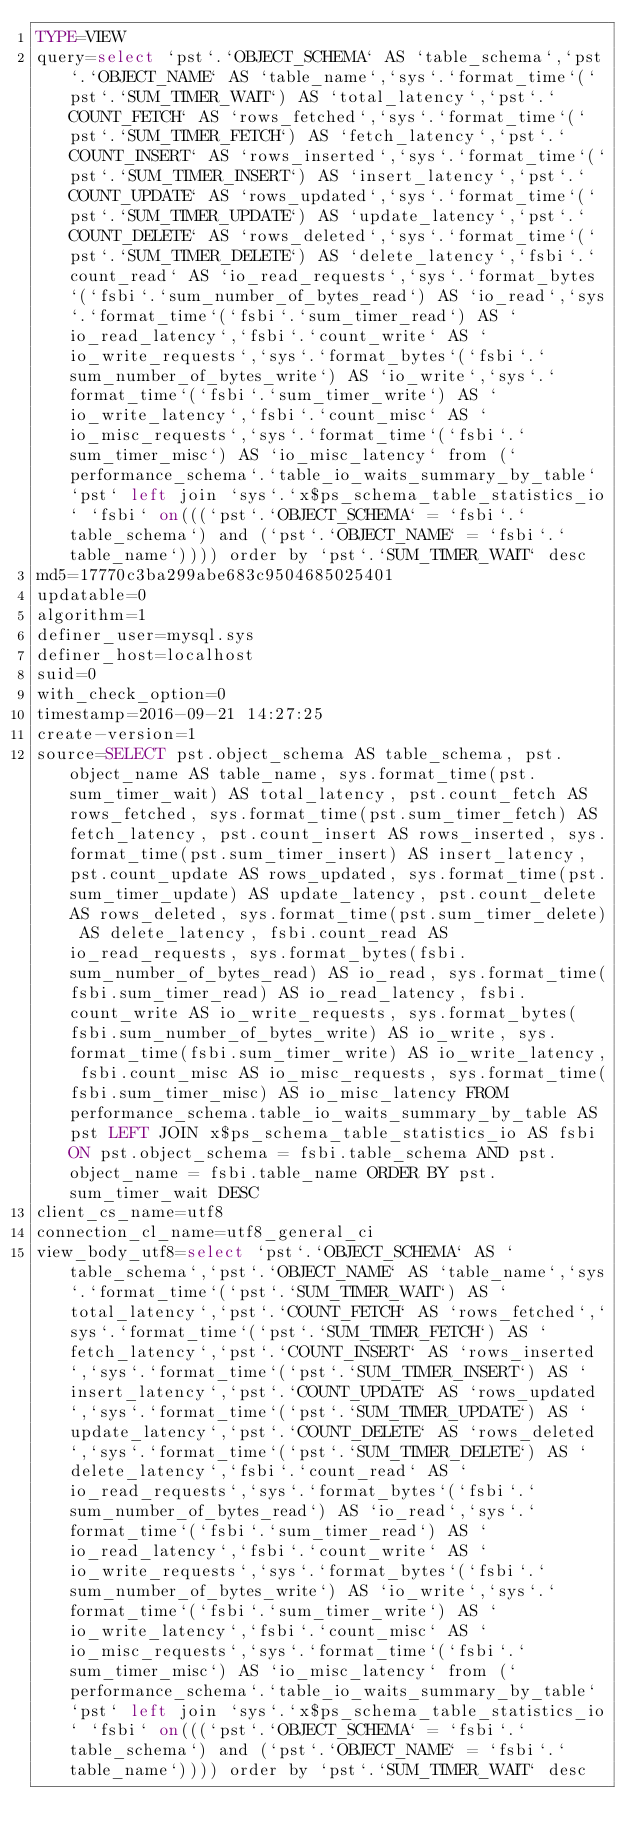Convert code to text. <code><loc_0><loc_0><loc_500><loc_500><_VisualBasic_>TYPE=VIEW
query=select `pst`.`OBJECT_SCHEMA` AS `table_schema`,`pst`.`OBJECT_NAME` AS `table_name`,`sys`.`format_time`(`pst`.`SUM_TIMER_WAIT`) AS `total_latency`,`pst`.`COUNT_FETCH` AS `rows_fetched`,`sys`.`format_time`(`pst`.`SUM_TIMER_FETCH`) AS `fetch_latency`,`pst`.`COUNT_INSERT` AS `rows_inserted`,`sys`.`format_time`(`pst`.`SUM_TIMER_INSERT`) AS `insert_latency`,`pst`.`COUNT_UPDATE` AS `rows_updated`,`sys`.`format_time`(`pst`.`SUM_TIMER_UPDATE`) AS `update_latency`,`pst`.`COUNT_DELETE` AS `rows_deleted`,`sys`.`format_time`(`pst`.`SUM_TIMER_DELETE`) AS `delete_latency`,`fsbi`.`count_read` AS `io_read_requests`,`sys`.`format_bytes`(`fsbi`.`sum_number_of_bytes_read`) AS `io_read`,`sys`.`format_time`(`fsbi`.`sum_timer_read`) AS `io_read_latency`,`fsbi`.`count_write` AS `io_write_requests`,`sys`.`format_bytes`(`fsbi`.`sum_number_of_bytes_write`) AS `io_write`,`sys`.`format_time`(`fsbi`.`sum_timer_write`) AS `io_write_latency`,`fsbi`.`count_misc` AS `io_misc_requests`,`sys`.`format_time`(`fsbi`.`sum_timer_misc`) AS `io_misc_latency` from (`performance_schema`.`table_io_waits_summary_by_table` `pst` left join `sys`.`x$ps_schema_table_statistics_io` `fsbi` on(((`pst`.`OBJECT_SCHEMA` = `fsbi`.`table_schema`) and (`pst`.`OBJECT_NAME` = `fsbi`.`table_name`)))) order by `pst`.`SUM_TIMER_WAIT` desc
md5=17770c3ba299abe683c9504685025401
updatable=0
algorithm=1
definer_user=mysql.sys
definer_host=localhost
suid=0
with_check_option=0
timestamp=2016-09-21 14:27:25
create-version=1
source=SELECT pst.object_schema AS table_schema, pst.object_name AS table_name, sys.format_time(pst.sum_timer_wait) AS total_latency, pst.count_fetch AS rows_fetched, sys.format_time(pst.sum_timer_fetch) AS fetch_latency, pst.count_insert AS rows_inserted, sys.format_time(pst.sum_timer_insert) AS insert_latency, pst.count_update AS rows_updated, sys.format_time(pst.sum_timer_update) AS update_latency, pst.count_delete AS rows_deleted, sys.format_time(pst.sum_timer_delete) AS delete_latency, fsbi.count_read AS io_read_requests, sys.format_bytes(fsbi.sum_number_of_bytes_read) AS io_read, sys.format_time(fsbi.sum_timer_read) AS io_read_latency, fsbi.count_write AS io_write_requests, sys.format_bytes(fsbi.sum_number_of_bytes_write) AS io_write, sys.format_time(fsbi.sum_timer_write) AS io_write_latency, fsbi.count_misc AS io_misc_requests, sys.format_time(fsbi.sum_timer_misc) AS io_misc_latency FROM performance_schema.table_io_waits_summary_by_table AS pst LEFT JOIN x$ps_schema_table_statistics_io AS fsbi ON pst.object_schema = fsbi.table_schema AND pst.object_name = fsbi.table_name ORDER BY pst.sum_timer_wait DESC
client_cs_name=utf8
connection_cl_name=utf8_general_ci
view_body_utf8=select `pst`.`OBJECT_SCHEMA` AS `table_schema`,`pst`.`OBJECT_NAME` AS `table_name`,`sys`.`format_time`(`pst`.`SUM_TIMER_WAIT`) AS `total_latency`,`pst`.`COUNT_FETCH` AS `rows_fetched`,`sys`.`format_time`(`pst`.`SUM_TIMER_FETCH`) AS `fetch_latency`,`pst`.`COUNT_INSERT` AS `rows_inserted`,`sys`.`format_time`(`pst`.`SUM_TIMER_INSERT`) AS `insert_latency`,`pst`.`COUNT_UPDATE` AS `rows_updated`,`sys`.`format_time`(`pst`.`SUM_TIMER_UPDATE`) AS `update_latency`,`pst`.`COUNT_DELETE` AS `rows_deleted`,`sys`.`format_time`(`pst`.`SUM_TIMER_DELETE`) AS `delete_latency`,`fsbi`.`count_read` AS `io_read_requests`,`sys`.`format_bytes`(`fsbi`.`sum_number_of_bytes_read`) AS `io_read`,`sys`.`format_time`(`fsbi`.`sum_timer_read`) AS `io_read_latency`,`fsbi`.`count_write` AS `io_write_requests`,`sys`.`format_bytes`(`fsbi`.`sum_number_of_bytes_write`) AS `io_write`,`sys`.`format_time`(`fsbi`.`sum_timer_write`) AS `io_write_latency`,`fsbi`.`count_misc` AS `io_misc_requests`,`sys`.`format_time`(`fsbi`.`sum_timer_misc`) AS `io_misc_latency` from (`performance_schema`.`table_io_waits_summary_by_table` `pst` left join `sys`.`x$ps_schema_table_statistics_io` `fsbi` on(((`pst`.`OBJECT_SCHEMA` = `fsbi`.`table_schema`) and (`pst`.`OBJECT_NAME` = `fsbi`.`table_name`)))) order by `pst`.`SUM_TIMER_WAIT` desc
</code> 